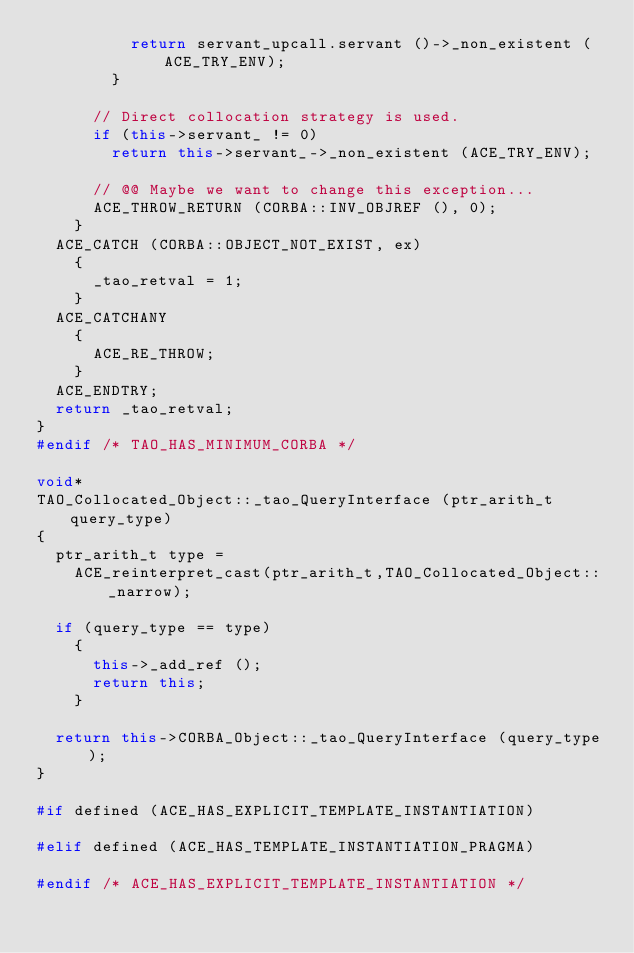<code> <loc_0><loc_0><loc_500><loc_500><_C++_>          return servant_upcall.servant ()->_non_existent (ACE_TRY_ENV);
        }

      // Direct collocation strategy is used.
      if (this->servant_ != 0)
        return this->servant_->_non_existent (ACE_TRY_ENV);

      // @@ Maybe we want to change this exception...
      ACE_THROW_RETURN (CORBA::INV_OBJREF (), 0);
    }
  ACE_CATCH (CORBA::OBJECT_NOT_EXIST, ex)
    {
      _tao_retval = 1;
    }
  ACE_CATCHANY
    {
      ACE_RE_THROW;
    }
  ACE_ENDTRY;
  return _tao_retval;
}
#endif /* TAO_HAS_MINIMUM_CORBA */

void*
TAO_Collocated_Object::_tao_QueryInterface (ptr_arith_t query_type)
{
  ptr_arith_t type =
    ACE_reinterpret_cast(ptr_arith_t,TAO_Collocated_Object::_narrow);

  if (query_type == type)
    {
      this->_add_ref ();
      return this;
    }

  return this->CORBA_Object::_tao_QueryInterface (query_type);
}

#if defined (ACE_HAS_EXPLICIT_TEMPLATE_INSTANTIATION)

#elif defined (ACE_HAS_TEMPLATE_INSTANTIATION_PRAGMA)

#endif /* ACE_HAS_EXPLICIT_TEMPLATE_INSTANTIATION */
</code> 